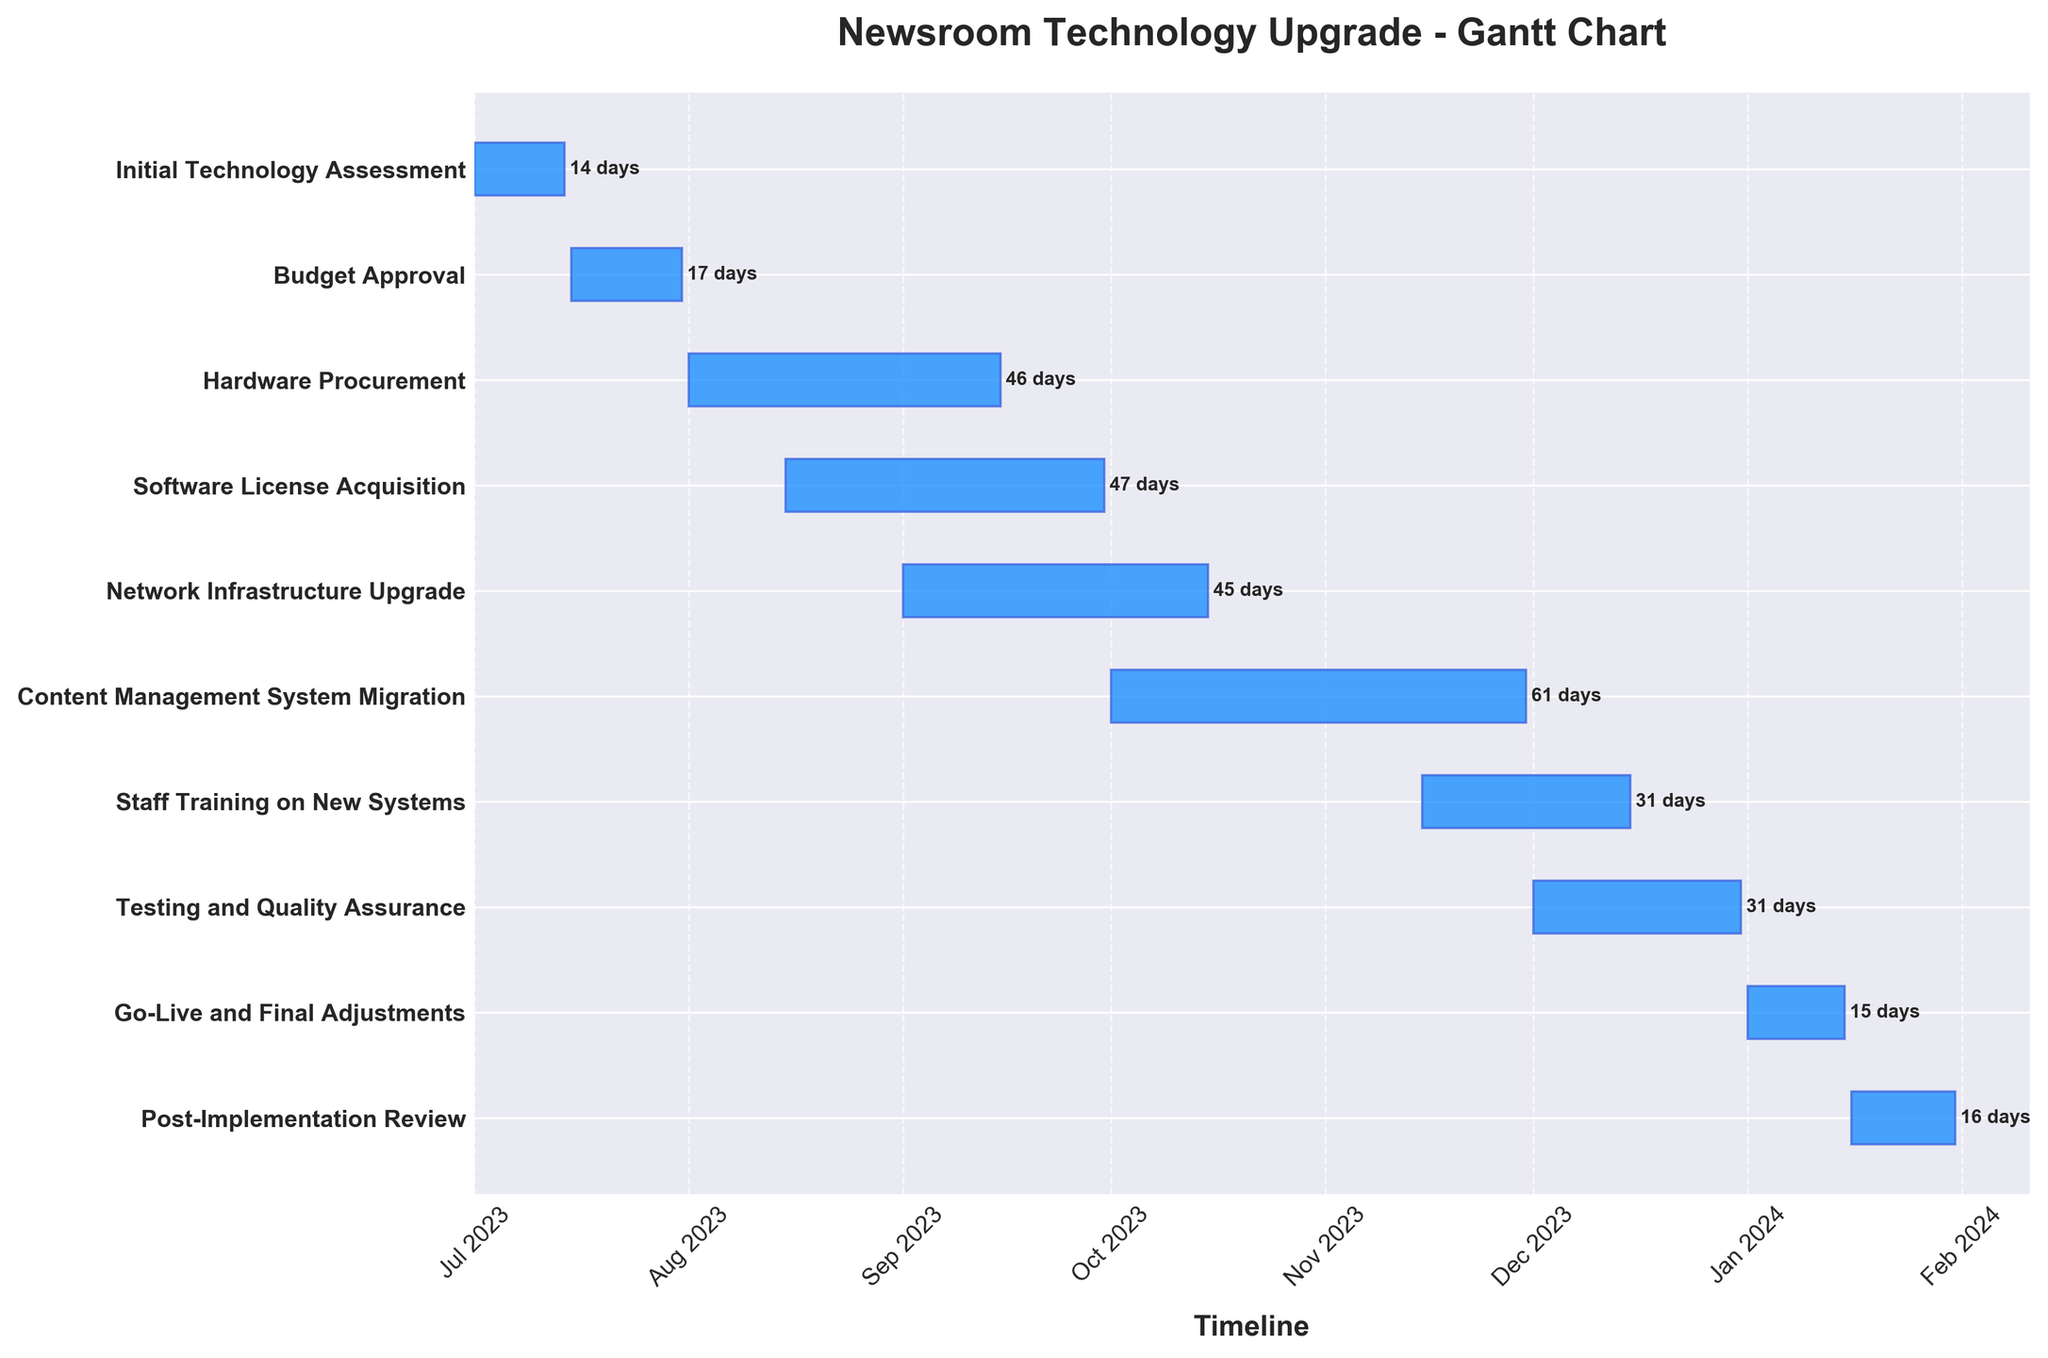Which task has the longest duration? Looking at the duration labels next to each task, we find that the "Content Management System Migration" has the longest duration of 61 days.
Answer: Content Management System Migration What is the title of the Gantt chart? The title of the Gantt chart is clearly displayed above the plot.
Answer: Newsroom Technology Upgrade - Gantt Chart How many tasks are shown in the Gantt Chart? By counting the number of tasks listed on the y-axis, we find there are 10 tasks.
Answer: 10 Which tasks overlap in the month of August? Observing the Gantt chart, "Hardware Procurement" and "Software License Acquisition" both start in August and extend beyond it.
Answer: Hardware Procurement, Software License Acquisition When does the "Network Infrastructure Upgrade" task start and end? The Gantt chart shows that the "Network Infrastructure Upgrade" starts on 2023-09-01 and ends on 2023-10-15.
Answer: 2023-09-01 to 2023-10-15 What is the total duration from the start of the "Initial Technology Assessment" to the end of "Post-Implementation Review"? The total duration can be calculated from the start of the "Initial Technology Assessment" (2023-07-01) to the end of "Post-Implementation Review" (2024-01-31). This spans from July 2023 to January 2024, inclusive of end dates, providing a total of 215 days considering leap year contributions.
Answer: 215 days Which task finishes right before "Go-Live and Final Adjustments" begins? The Gantt chart shows that "Testing and Quality Assurance" ends on 2023-12-31, which is right before "Go-Live and Final Adjustments" begins on 2024-01-01.
Answer: Testing and Quality Assurance Which task has the same duration as "Staff Training on New Systems"? Observing the duration labels, both "Staff Training on New Systems" and "Testing and Quality Assurance" have a duration of 31 days.
Answer: Testing and Quality Assurance What month does "Content Management System Migration" span completely? The "Content Management System Migration" starts on 2023-10-01 and ends on 2023-11-30, which means it spans the entire month of November 2023.
Answer: November 2023 Which task has the shortest duration? Looking at the duration labels, "Go-Live and Final Adjustments" has the shortest duration of 15 days.
Answer: Go-Live and Final Adjustments 